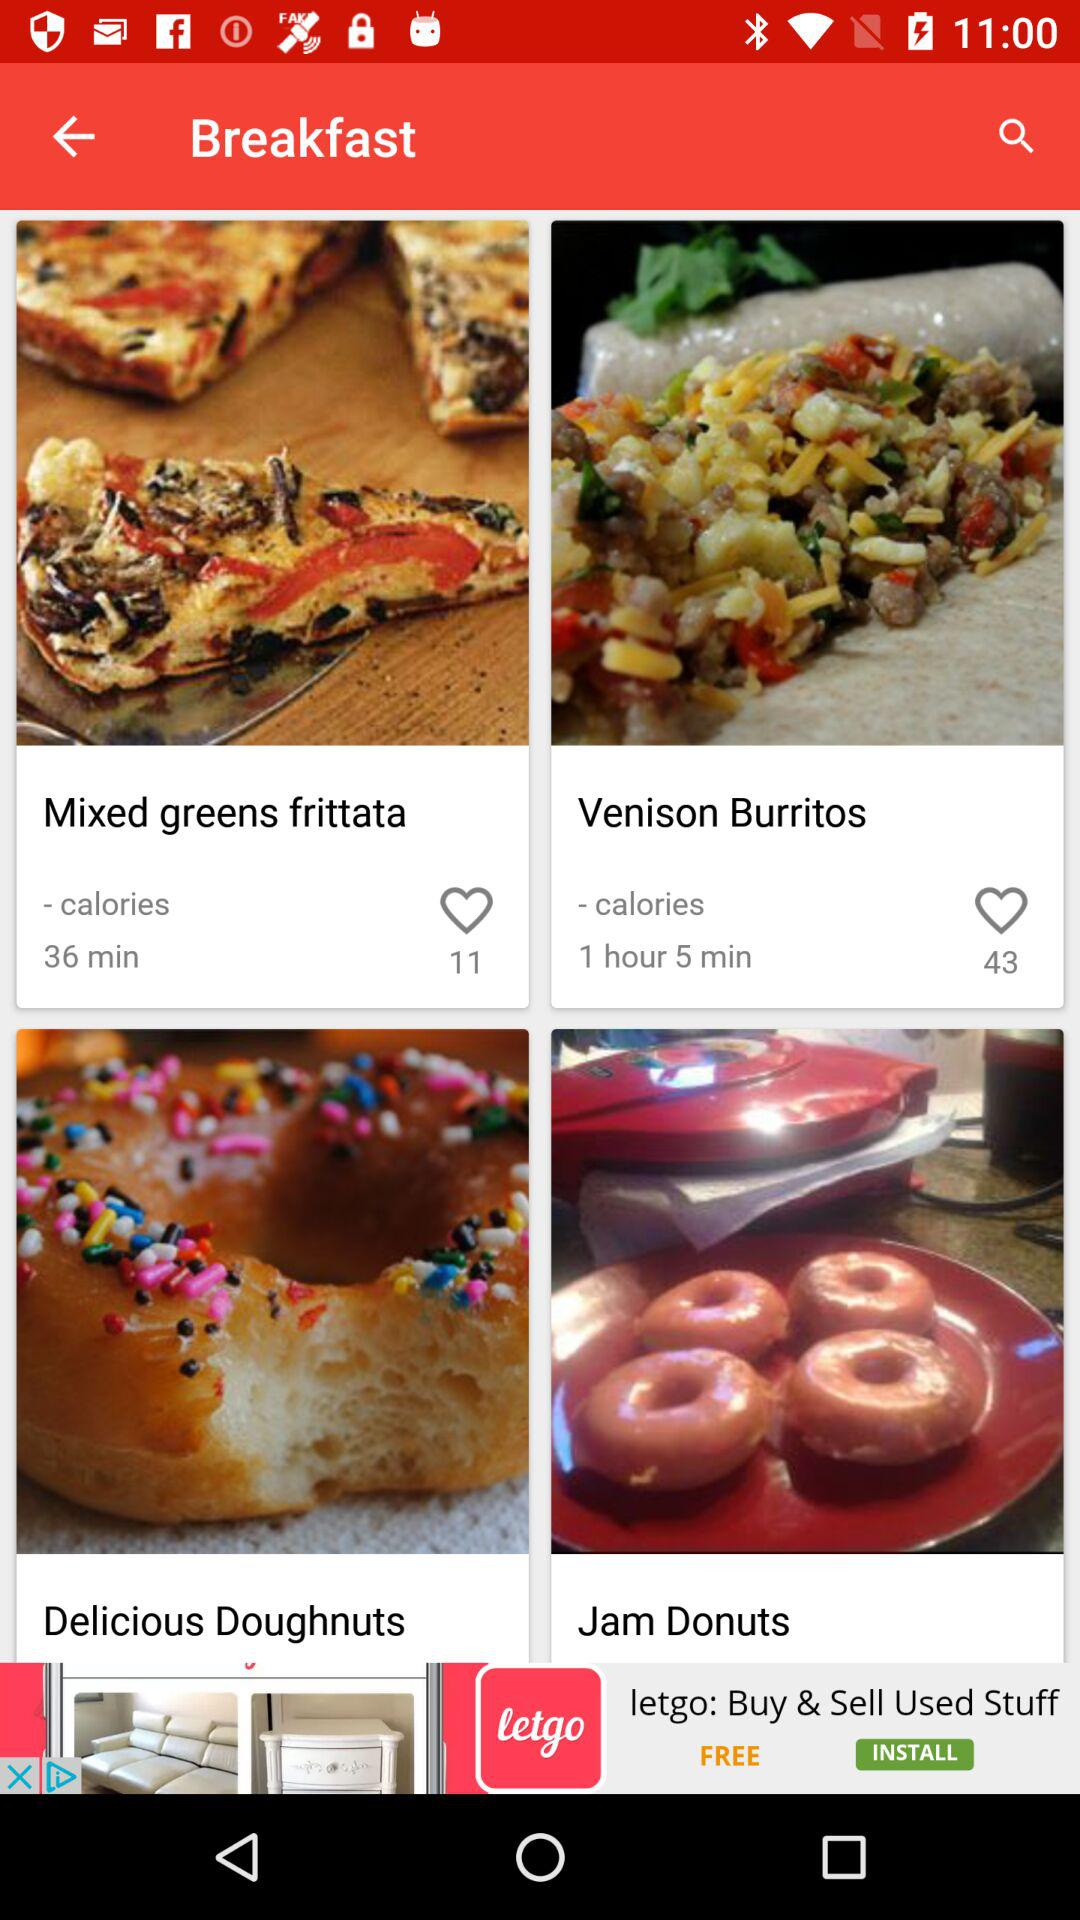How many people like Venison Burritos? There are 43 people who like Venison Burritos. 